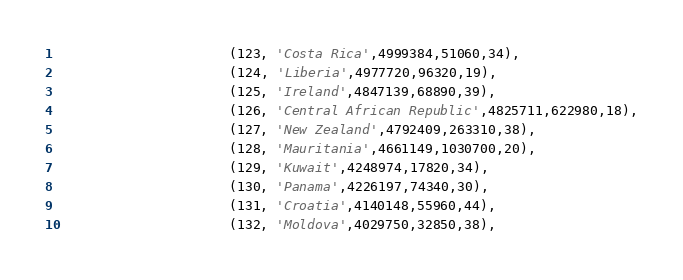Convert code to text. <code><loc_0><loc_0><loc_500><loc_500><_SQL_>                      (123, 'Costa Rica',4999384,51060,34),
                      (124, 'Liberia',4977720,96320,19),
                      (125, 'Ireland',4847139,68890,39),
                      (126, 'Central African Republic',4825711,622980,18),
                      (127, 'New Zealand',4792409,263310,38),
                      (128, 'Mauritania',4661149,1030700,20),
                      (129, 'Kuwait',4248974,17820,34),
                      (130, 'Panama',4226197,74340,30),
                      (131, 'Croatia',4140148,55960,44),
                      (132, 'Moldova',4029750,32850,38),</code> 